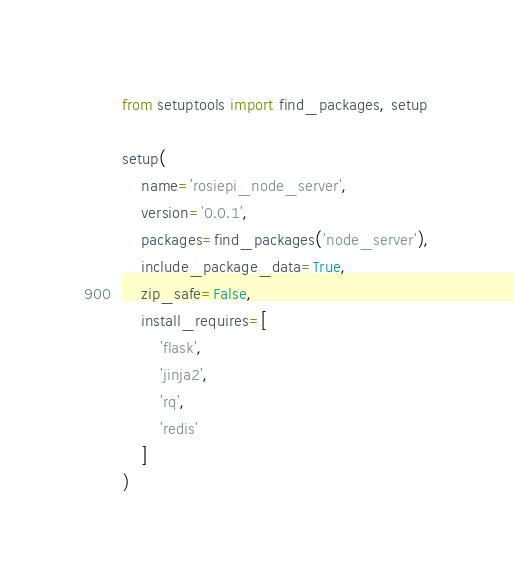<code> <loc_0><loc_0><loc_500><loc_500><_Python_>from setuptools import find_packages, setup

setup(
    name='rosiepi_node_server',
    version='0.0.1',
    packages=find_packages('node_server'),
    include_package_data=True,
    zip_safe=False,
    install_requires=[
        'flask',
        'jinja2',
        'rq',
        'redis'
    ]
)
</code> 